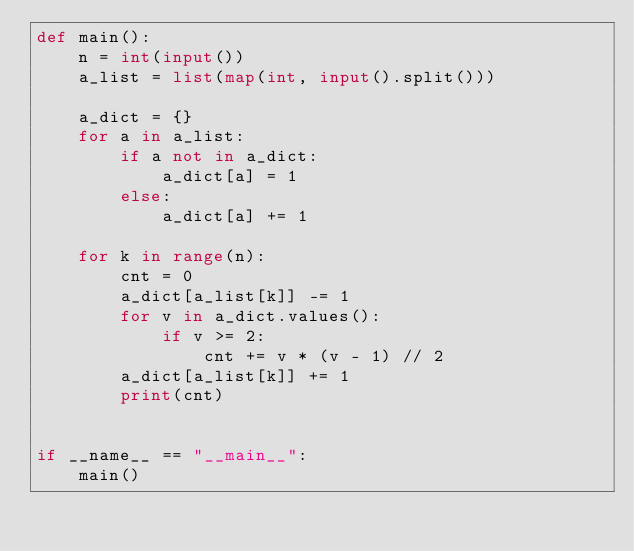Convert code to text. <code><loc_0><loc_0><loc_500><loc_500><_Python_>def main():
    n = int(input())
    a_list = list(map(int, input().split()))

    a_dict = {}
    for a in a_list:
        if a not in a_dict:
            a_dict[a] = 1
        else:
            a_dict[a] += 1

    for k in range(n):
        cnt = 0
        a_dict[a_list[k]] -= 1
        for v in a_dict.values():
            if v >= 2:
                cnt += v * (v - 1) // 2
        a_dict[a_list[k]] += 1
        print(cnt)


if __name__ == "__main__":
    main()
</code> 